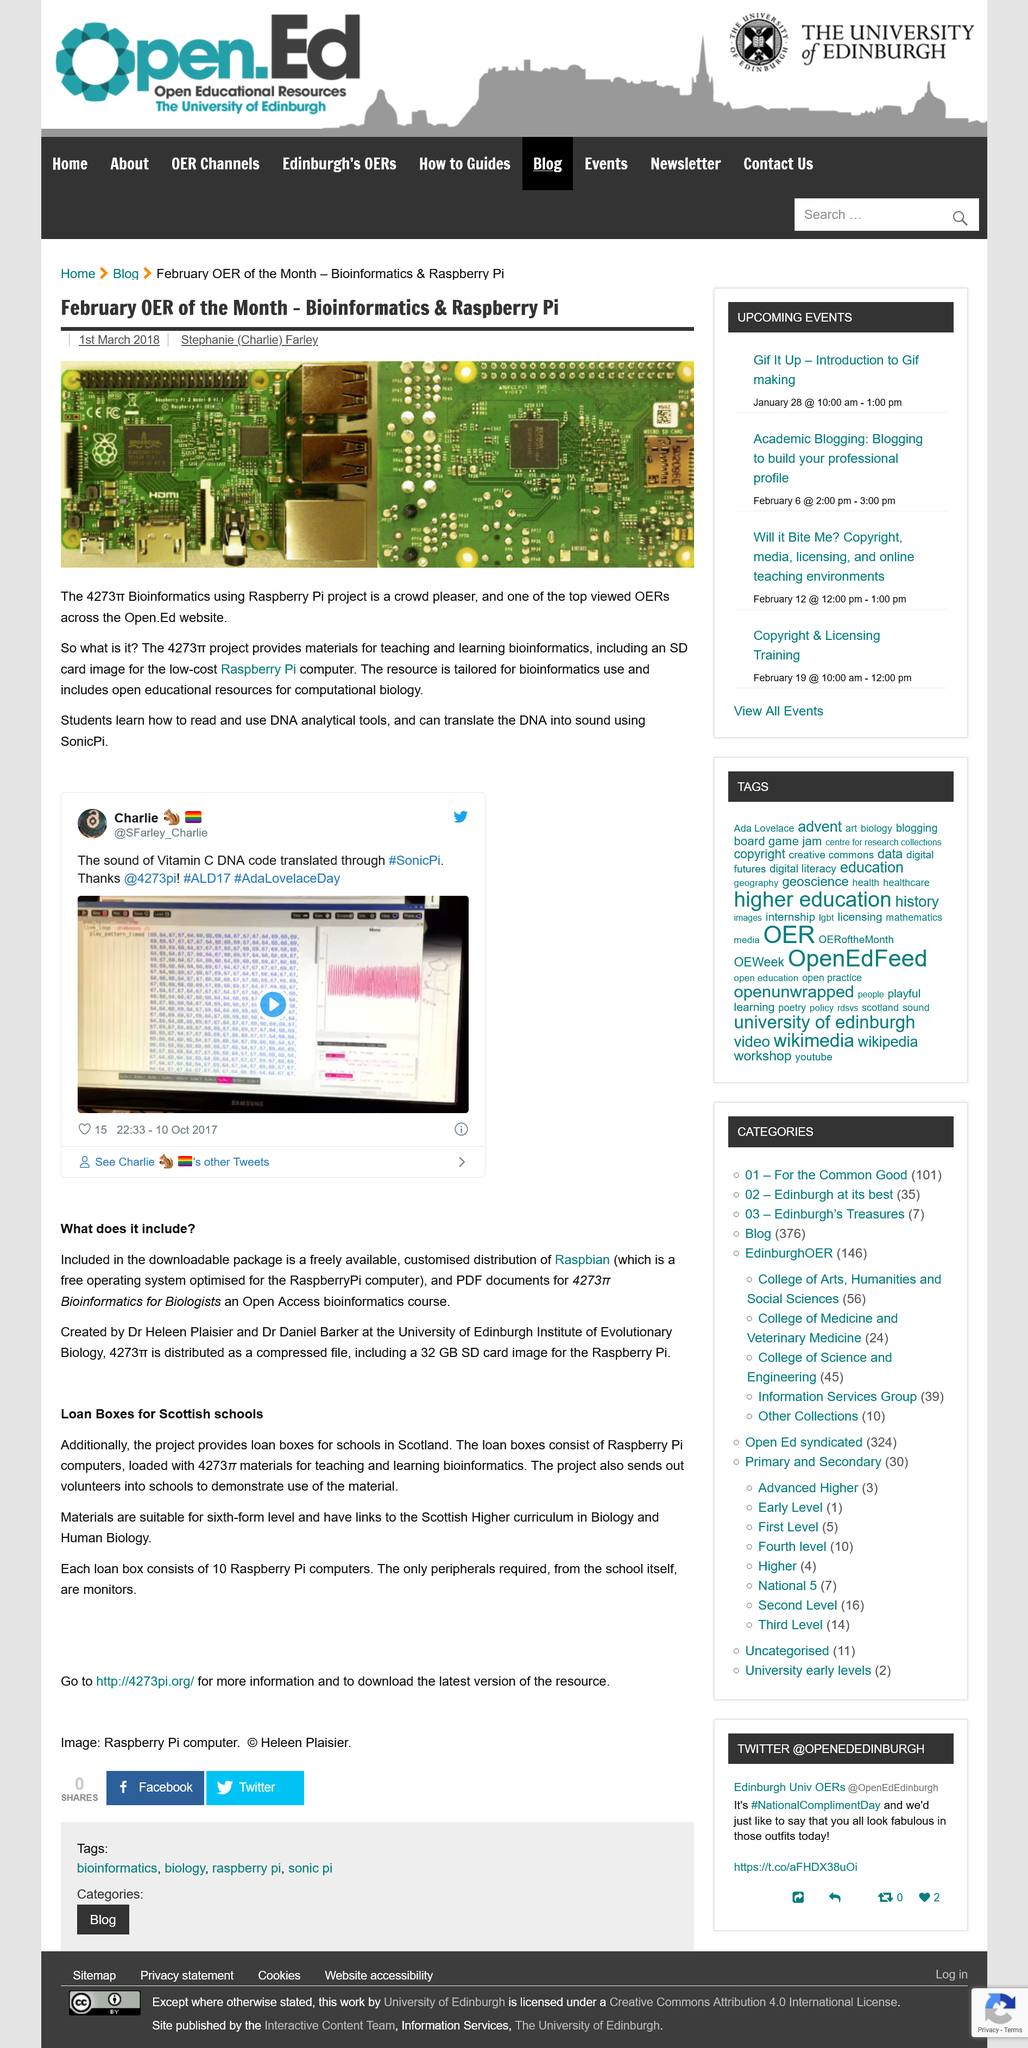Mention a couple of crucial points in this snapshot. The article on Bioinformatics & Raspberry Pi is authored by Stephanie (Charlie) Farley. Students can learn how to read and use DNA analytical tools, making it possible for them to participate in this field. On March 1st, 2018, the article on bioinformatics and Raspberry Pi was published. 